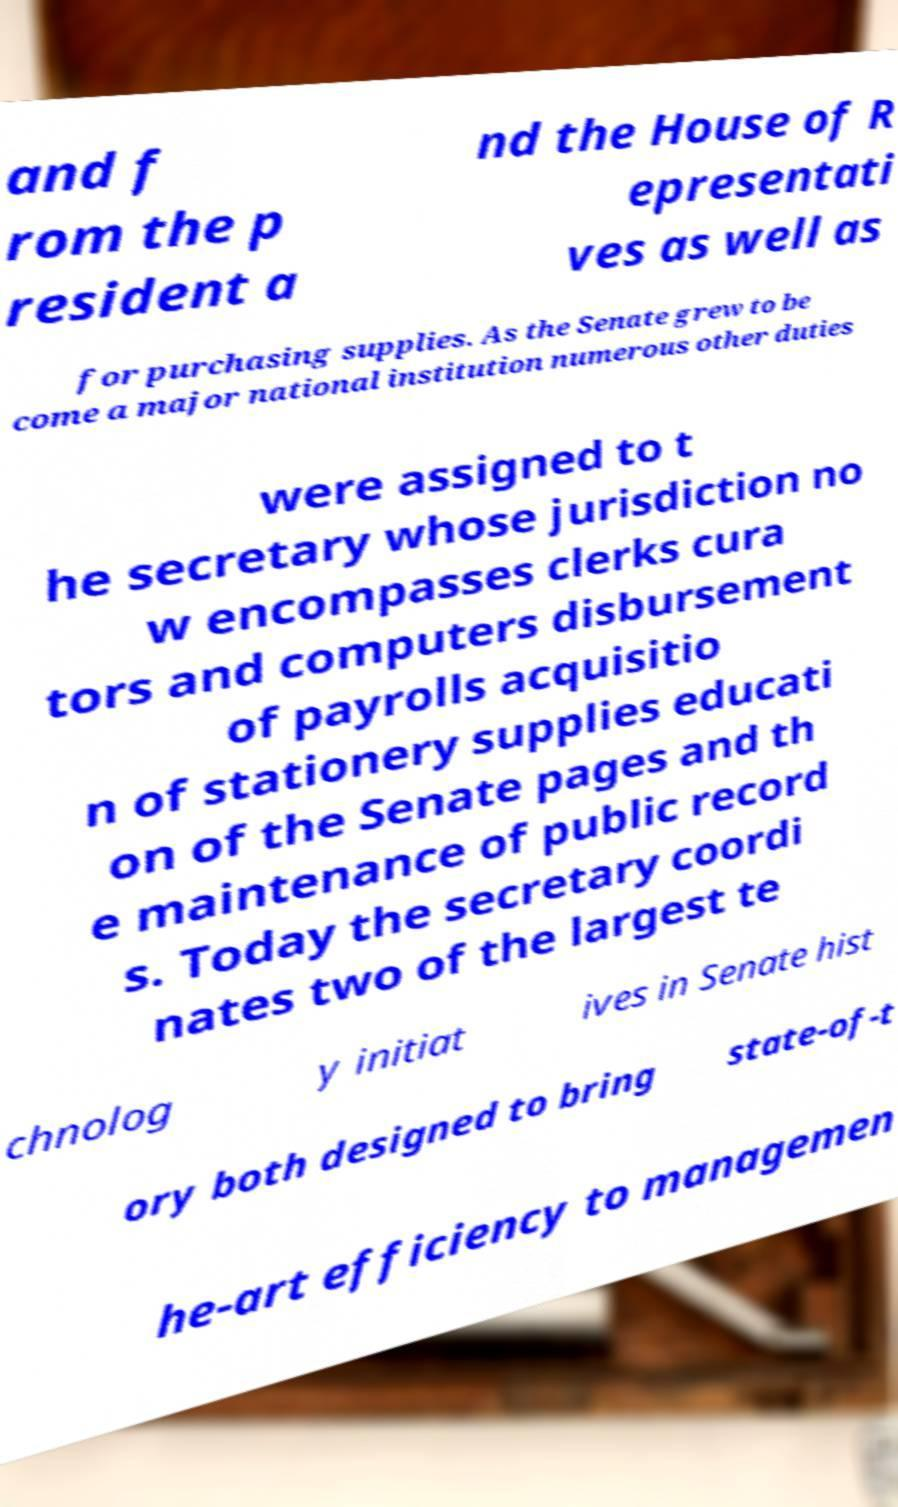Please read and relay the text visible in this image. What does it say? and f rom the p resident a nd the House of R epresentati ves as well as for purchasing supplies. As the Senate grew to be come a major national institution numerous other duties were assigned to t he secretary whose jurisdiction no w encompasses clerks cura tors and computers disbursement of payrolls acquisitio n of stationery supplies educati on of the Senate pages and th e maintenance of public record s. Today the secretary coordi nates two of the largest te chnolog y initiat ives in Senate hist ory both designed to bring state-of-t he-art efficiency to managemen 